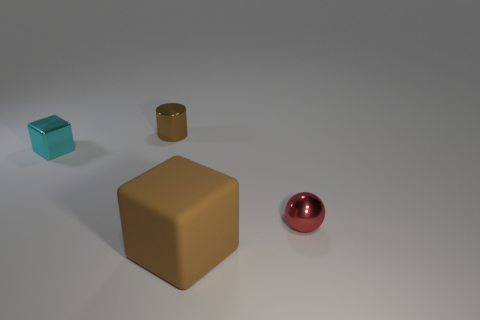Comparing the sizes of the objects, what can we infer about their relative distances? The different sizes of the objects suggest that they are placed at varying distances from the viewer. The largest brown cube is likely the closest, followed by the reddish sphere. The smaller cyan cube and the tiny brown cube behind the sphere seem to be further away, with their smaller sizes implying they are at a greater distance. This creates a sense of depth in the image. 